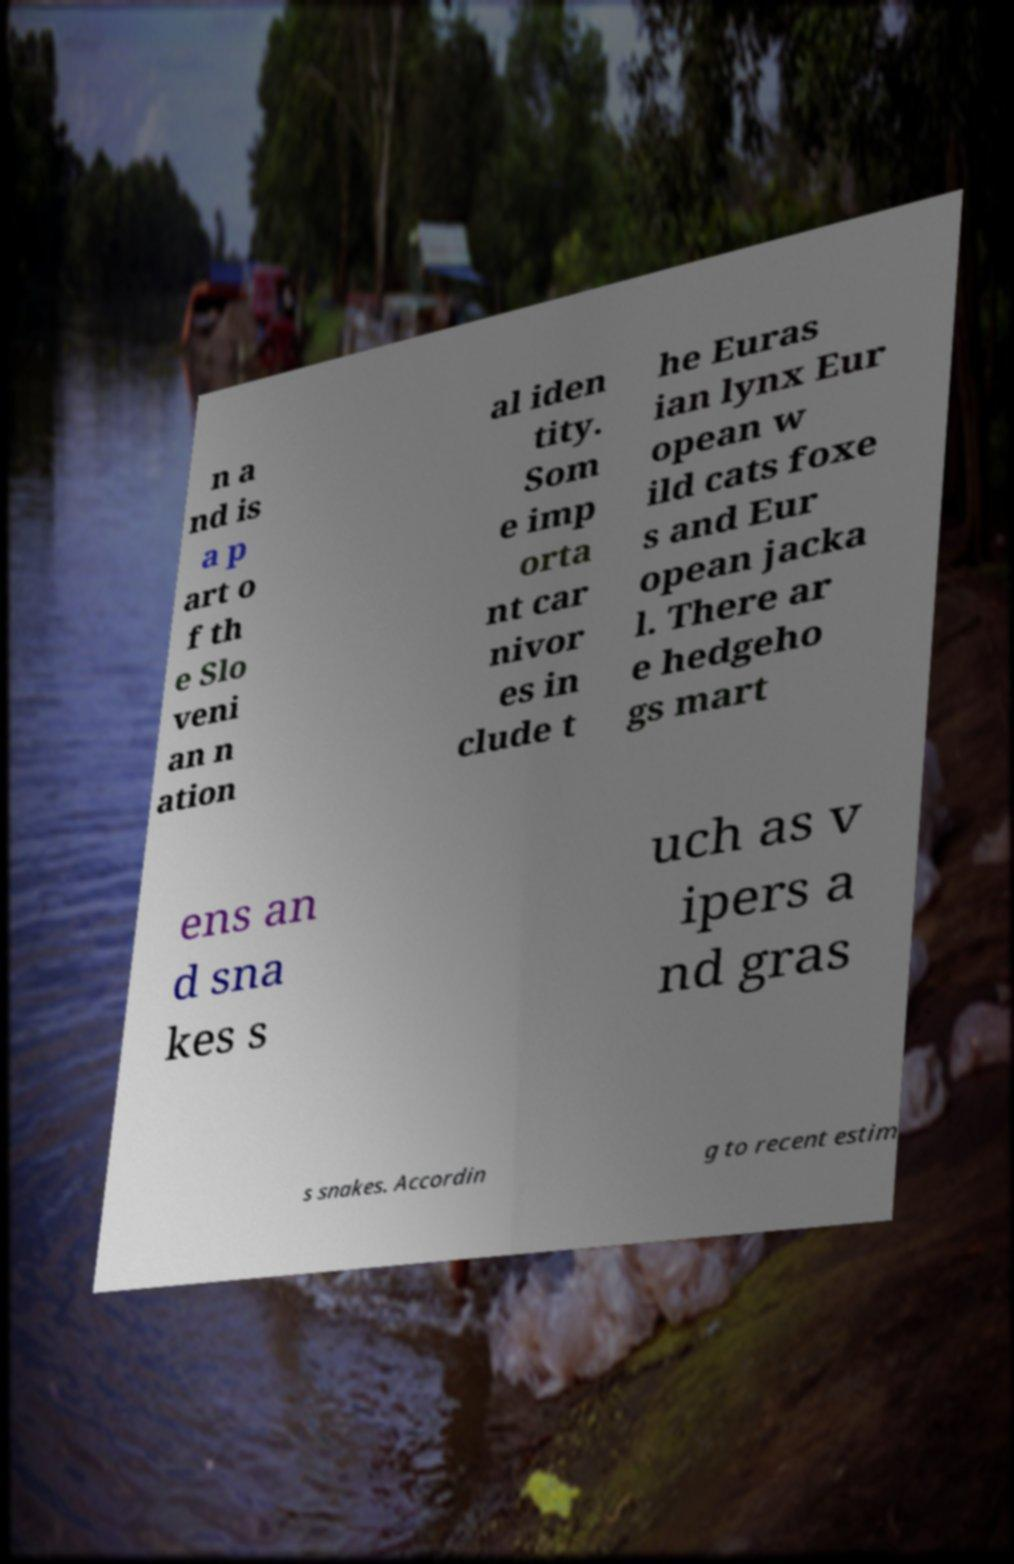Can you accurately transcribe the text from the provided image for me? n a nd is a p art o f th e Slo veni an n ation al iden tity. Som e imp orta nt car nivor es in clude t he Euras ian lynx Eur opean w ild cats foxe s and Eur opean jacka l. There ar e hedgeho gs mart ens an d sna kes s uch as v ipers a nd gras s snakes. Accordin g to recent estim 